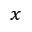<formula> <loc_0><loc_0><loc_500><loc_500>_ { x }</formula> 